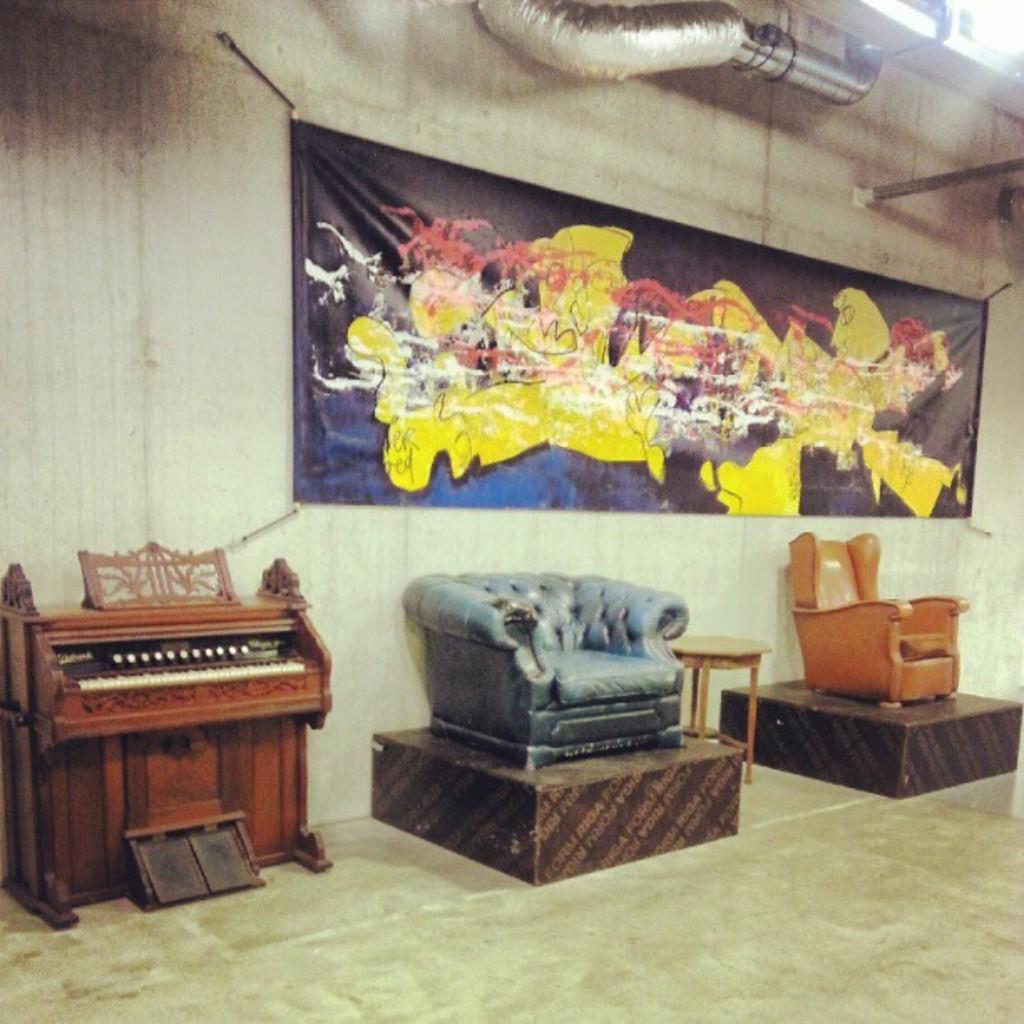What type of furniture is present in the image? There is a couch and a chair in the image. What other object can be seen in the image? There is a piano in the image. How many cats are sitting on the piano in the image? There are no cats present in the image. What reward can be seen on the couch in the image? There is no reward visible on the couch in the image. 